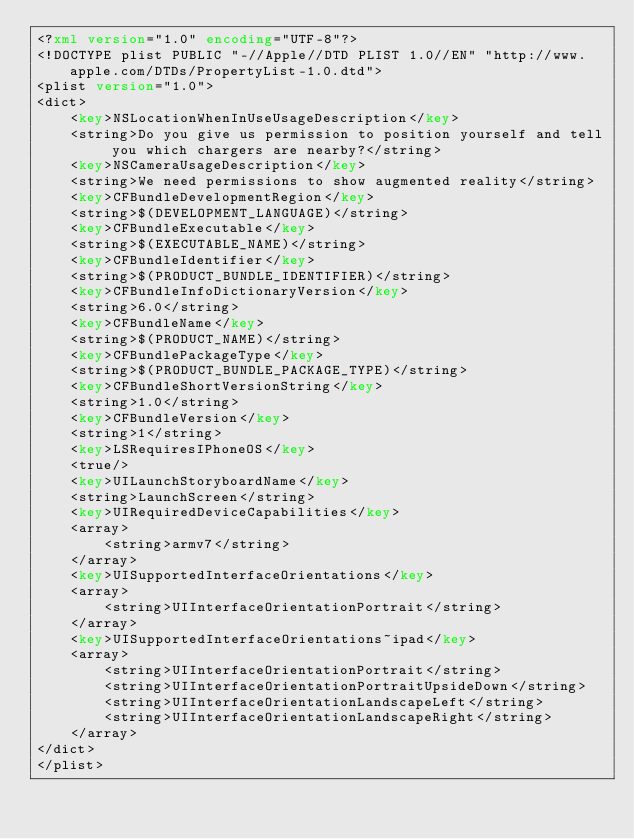Convert code to text. <code><loc_0><loc_0><loc_500><loc_500><_XML_><?xml version="1.0" encoding="UTF-8"?>
<!DOCTYPE plist PUBLIC "-//Apple//DTD PLIST 1.0//EN" "http://www.apple.com/DTDs/PropertyList-1.0.dtd">
<plist version="1.0">
<dict>
	<key>NSLocationWhenInUseUsageDescription</key>
	<string>Do you give us permission to position yourself and tell you which chargers are nearby?</string>
	<key>NSCameraUsageDescription</key>
	<string>We need permissions to show augmented reality</string>
	<key>CFBundleDevelopmentRegion</key>
	<string>$(DEVELOPMENT_LANGUAGE)</string>
	<key>CFBundleExecutable</key>
	<string>$(EXECUTABLE_NAME)</string>
	<key>CFBundleIdentifier</key>
	<string>$(PRODUCT_BUNDLE_IDENTIFIER)</string>
	<key>CFBundleInfoDictionaryVersion</key>
	<string>6.0</string>
	<key>CFBundleName</key>
	<string>$(PRODUCT_NAME)</string>
	<key>CFBundlePackageType</key>
	<string>$(PRODUCT_BUNDLE_PACKAGE_TYPE)</string>
	<key>CFBundleShortVersionString</key>
	<string>1.0</string>
	<key>CFBundleVersion</key>
	<string>1</string>
	<key>LSRequiresIPhoneOS</key>
	<true/>
	<key>UILaunchStoryboardName</key>
	<string>LaunchScreen</string>
	<key>UIRequiredDeviceCapabilities</key>
	<array>
		<string>armv7</string>
	</array>
	<key>UISupportedInterfaceOrientations</key>
	<array>
		<string>UIInterfaceOrientationPortrait</string>
	</array>
	<key>UISupportedInterfaceOrientations~ipad</key>
	<array>
		<string>UIInterfaceOrientationPortrait</string>
		<string>UIInterfaceOrientationPortraitUpsideDown</string>
		<string>UIInterfaceOrientationLandscapeLeft</string>
		<string>UIInterfaceOrientationLandscapeRight</string>
	</array>
</dict>
</plist>
</code> 